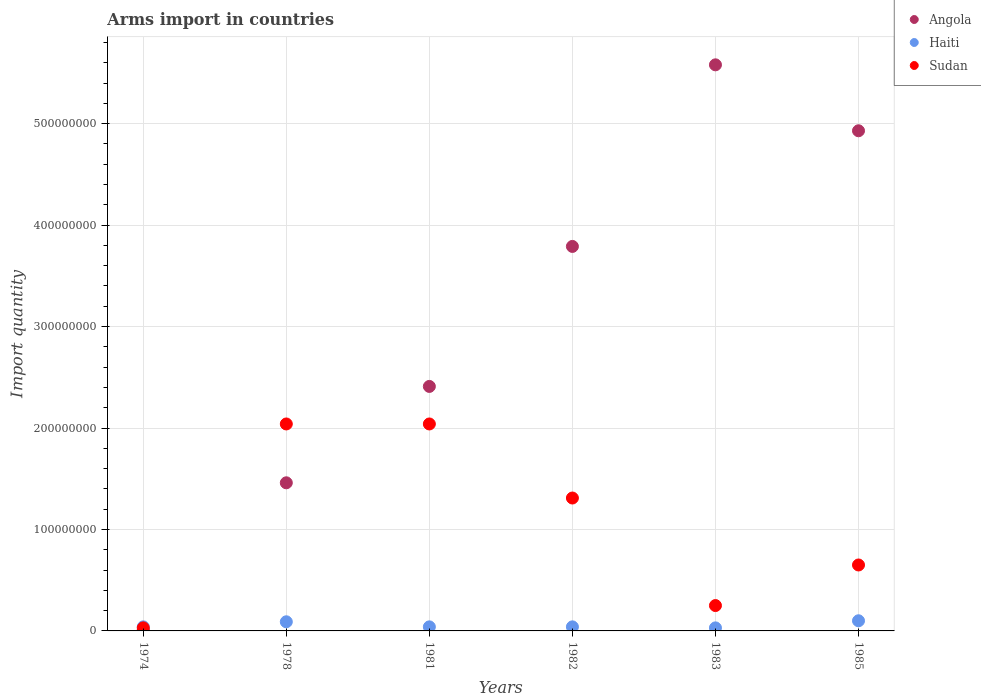What is the total arms import in Angola in 1978?
Offer a very short reply. 1.46e+08. Across all years, what is the maximum total arms import in Haiti?
Ensure brevity in your answer.  1.00e+07. Across all years, what is the minimum total arms import in Haiti?
Provide a short and direct response. 3.00e+06. In which year was the total arms import in Angola minimum?
Give a very brief answer. 1974. What is the total total arms import in Angola in the graph?
Your answer should be very brief. 1.82e+09. What is the difference between the total arms import in Sudan in 1982 and that in 1983?
Your answer should be very brief. 1.06e+08. What is the average total arms import in Angola per year?
Keep it short and to the point. 3.03e+08. In the year 1982, what is the difference between the total arms import in Haiti and total arms import in Angola?
Keep it short and to the point. -3.75e+08. What is the ratio of the total arms import in Haiti in 1974 to that in 1983?
Ensure brevity in your answer.  1.33. Is it the case that in every year, the sum of the total arms import in Sudan and total arms import in Haiti  is greater than the total arms import in Angola?
Offer a very short reply. No. How many dotlines are there?
Your answer should be very brief. 3. How many years are there in the graph?
Give a very brief answer. 6. Are the values on the major ticks of Y-axis written in scientific E-notation?
Offer a terse response. No. Does the graph contain grids?
Ensure brevity in your answer.  Yes. How are the legend labels stacked?
Provide a succinct answer. Vertical. What is the title of the graph?
Offer a terse response. Arms import in countries. Does "Tonga" appear as one of the legend labels in the graph?
Offer a very short reply. No. What is the label or title of the Y-axis?
Offer a terse response. Import quantity. What is the Import quantity of Sudan in 1974?
Make the answer very short. 3.00e+06. What is the Import quantity of Angola in 1978?
Ensure brevity in your answer.  1.46e+08. What is the Import quantity of Haiti in 1978?
Your answer should be very brief. 9.00e+06. What is the Import quantity of Sudan in 1978?
Provide a short and direct response. 2.04e+08. What is the Import quantity in Angola in 1981?
Your response must be concise. 2.41e+08. What is the Import quantity of Sudan in 1981?
Offer a terse response. 2.04e+08. What is the Import quantity of Angola in 1982?
Provide a succinct answer. 3.79e+08. What is the Import quantity in Sudan in 1982?
Offer a very short reply. 1.31e+08. What is the Import quantity of Angola in 1983?
Your answer should be very brief. 5.58e+08. What is the Import quantity of Haiti in 1983?
Offer a terse response. 3.00e+06. What is the Import quantity of Sudan in 1983?
Offer a very short reply. 2.50e+07. What is the Import quantity in Angola in 1985?
Ensure brevity in your answer.  4.93e+08. What is the Import quantity in Sudan in 1985?
Keep it short and to the point. 6.50e+07. Across all years, what is the maximum Import quantity in Angola?
Your answer should be very brief. 5.58e+08. Across all years, what is the maximum Import quantity of Sudan?
Offer a terse response. 2.04e+08. Across all years, what is the minimum Import quantity of Angola?
Ensure brevity in your answer.  1.00e+06. Across all years, what is the minimum Import quantity of Haiti?
Ensure brevity in your answer.  3.00e+06. Across all years, what is the minimum Import quantity in Sudan?
Give a very brief answer. 3.00e+06. What is the total Import quantity in Angola in the graph?
Your response must be concise. 1.82e+09. What is the total Import quantity of Haiti in the graph?
Make the answer very short. 3.40e+07. What is the total Import quantity of Sudan in the graph?
Provide a short and direct response. 6.32e+08. What is the difference between the Import quantity of Angola in 1974 and that in 1978?
Give a very brief answer. -1.45e+08. What is the difference between the Import quantity of Haiti in 1974 and that in 1978?
Provide a short and direct response. -5.00e+06. What is the difference between the Import quantity of Sudan in 1974 and that in 1978?
Ensure brevity in your answer.  -2.01e+08. What is the difference between the Import quantity of Angola in 1974 and that in 1981?
Offer a very short reply. -2.40e+08. What is the difference between the Import quantity of Haiti in 1974 and that in 1981?
Your answer should be very brief. 0. What is the difference between the Import quantity of Sudan in 1974 and that in 1981?
Give a very brief answer. -2.01e+08. What is the difference between the Import quantity of Angola in 1974 and that in 1982?
Your answer should be very brief. -3.78e+08. What is the difference between the Import quantity of Sudan in 1974 and that in 1982?
Give a very brief answer. -1.28e+08. What is the difference between the Import quantity in Angola in 1974 and that in 1983?
Your answer should be compact. -5.57e+08. What is the difference between the Import quantity in Haiti in 1974 and that in 1983?
Provide a succinct answer. 1.00e+06. What is the difference between the Import quantity of Sudan in 1974 and that in 1983?
Your answer should be compact. -2.20e+07. What is the difference between the Import quantity of Angola in 1974 and that in 1985?
Make the answer very short. -4.92e+08. What is the difference between the Import quantity of Haiti in 1974 and that in 1985?
Your answer should be compact. -6.00e+06. What is the difference between the Import quantity in Sudan in 1974 and that in 1985?
Your answer should be very brief. -6.20e+07. What is the difference between the Import quantity of Angola in 1978 and that in 1981?
Your answer should be compact. -9.50e+07. What is the difference between the Import quantity in Haiti in 1978 and that in 1981?
Ensure brevity in your answer.  5.00e+06. What is the difference between the Import quantity in Sudan in 1978 and that in 1981?
Keep it short and to the point. 0. What is the difference between the Import quantity in Angola in 1978 and that in 1982?
Your answer should be compact. -2.33e+08. What is the difference between the Import quantity of Sudan in 1978 and that in 1982?
Provide a succinct answer. 7.30e+07. What is the difference between the Import quantity in Angola in 1978 and that in 1983?
Your answer should be compact. -4.12e+08. What is the difference between the Import quantity of Sudan in 1978 and that in 1983?
Ensure brevity in your answer.  1.79e+08. What is the difference between the Import quantity in Angola in 1978 and that in 1985?
Your response must be concise. -3.47e+08. What is the difference between the Import quantity in Sudan in 1978 and that in 1985?
Your answer should be compact. 1.39e+08. What is the difference between the Import quantity of Angola in 1981 and that in 1982?
Make the answer very short. -1.38e+08. What is the difference between the Import quantity of Sudan in 1981 and that in 1982?
Ensure brevity in your answer.  7.30e+07. What is the difference between the Import quantity of Angola in 1981 and that in 1983?
Your response must be concise. -3.17e+08. What is the difference between the Import quantity in Haiti in 1981 and that in 1983?
Your answer should be very brief. 1.00e+06. What is the difference between the Import quantity in Sudan in 1981 and that in 1983?
Your answer should be compact. 1.79e+08. What is the difference between the Import quantity in Angola in 1981 and that in 1985?
Your answer should be very brief. -2.52e+08. What is the difference between the Import quantity in Haiti in 1981 and that in 1985?
Provide a short and direct response. -6.00e+06. What is the difference between the Import quantity of Sudan in 1981 and that in 1985?
Offer a very short reply. 1.39e+08. What is the difference between the Import quantity of Angola in 1982 and that in 1983?
Offer a terse response. -1.79e+08. What is the difference between the Import quantity in Sudan in 1982 and that in 1983?
Your answer should be compact. 1.06e+08. What is the difference between the Import quantity in Angola in 1982 and that in 1985?
Offer a terse response. -1.14e+08. What is the difference between the Import quantity in Haiti in 1982 and that in 1985?
Offer a terse response. -6.00e+06. What is the difference between the Import quantity of Sudan in 1982 and that in 1985?
Your answer should be compact. 6.60e+07. What is the difference between the Import quantity of Angola in 1983 and that in 1985?
Offer a very short reply. 6.50e+07. What is the difference between the Import quantity of Haiti in 1983 and that in 1985?
Your answer should be very brief. -7.00e+06. What is the difference between the Import quantity in Sudan in 1983 and that in 1985?
Keep it short and to the point. -4.00e+07. What is the difference between the Import quantity in Angola in 1974 and the Import quantity in Haiti in 1978?
Give a very brief answer. -8.00e+06. What is the difference between the Import quantity of Angola in 1974 and the Import quantity of Sudan in 1978?
Your response must be concise. -2.03e+08. What is the difference between the Import quantity of Haiti in 1974 and the Import quantity of Sudan in 1978?
Keep it short and to the point. -2.00e+08. What is the difference between the Import quantity of Angola in 1974 and the Import quantity of Sudan in 1981?
Give a very brief answer. -2.03e+08. What is the difference between the Import quantity in Haiti in 1974 and the Import quantity in Sudan in 1981?
Offer a very short reply. -2.00e+08. What is the difference between the Import quantity in Angola in 1974 and the Import quantity in Haiti in 1982?
Give a very brief answer. -3.00e+06. What is the difference between the Import quantity in Angola in 1974 and the Import quantity in Sudan in 1982?
Provide a succinct answer. -1.30e+08. What is the difference between the Import quantity of Haiti in 1974 and the Import quantity of Sudan in 1982?
Your answer should be compact. -1.27e+08. What is the difference between the Import quantity of Angola in 1974 and the Import quantity of Sudan in 1983?
Provide a short and direct response. -2.40e+07. What is the difference between the Import quantity in Haiti in 1974 and the Import quantity in Sudan in 1983?
Keep it short and to the point. -2.10e+07. What is the difference between the Import quantity in Angola in 1974 and the Import quantity in Haiti in 1985?
Your answer should be compact. -9.00e+06. What is the difference between the Import quantity of Angola in 1974 and the Import quantity of Sudan in 1985?
Provide a short and direct response. -6.40e+07. What is the difference between the Import quantity of Haiti in 1974 and the Import quantity of Sudan in 1985?
Provide a short and direct response. -6.10e+07. What is the difference between the Import quantity of Angola in 1978 and the Import quantity of Haiti in 1981?
Keep it short and to the point. 1.42e+08. What is the difference between the Import quantity of Angola in 1978 and the Import quantity of Sudan in 1981?
Provide a short and direct response. -5.80e+07. What is the difference between the Import quantity in Haiti in 1978 and the Import quantity in Sudan in 1981?
Ensure brevity in your answer.  -1.95e+08. What is the difference between the Import quantity of Angola in 1978 and the Import quantity of Haiti in 1982?
Keep it short and to the point. 1.42e+08. What is the difference between the Import quantity in Angola in 1978 and the Import quantity in Sudan in 1982?
Provide a succinct answer. 1.50e+07. What is the difference between the Import quantity in Haiti in 1978 and the Import quantity in Sudan in 1982?
Provide a succinct answer. -1.22e+08. What is the difference between the Import quantity in Angola in 1978 and the Import quantity in Haiti in 1983?
Your answer should be very brief. 1.43e+08. What is the difference between the Import quantity of Angola in 1978 and the Import quantity of Sudan in 1983?
Keep it short and to the point. 1.21e+08. What is the difference between the Import quantity in Haiti in 1978 and the Import quantity in Sudan in 1983?
Give a very brief answer. -1.60e+07. What is the difference between the Import quantity in Angola in 1978 and the Import quantity in Haiti in 1985?
Give a very brief answer. 1.36e+08. What is the difference between the Import quantity in Angola in 1978 and the Import quantity in Sudan in 1985?
Your response must be concise. 8.10e+07. What is the difference between the Import quantity in Haiti in 1978 and the Import quantity in Sudan in 1985?
Your answer should be compact. -5.60e+07. What is the difference between the Import quantity of Angola in 1981 and the Import quantity of Haiti in 1982?
Your answer should be very brief. 2.37e+08. What is the difference between the Import quantity in Angola in 1981 and the Import quantity in Sudan in 1982?
Keep it short and to the point. 1.10e+08. What is the difference between the Import quantity of Haiti in 1981 and the Import quantity of Sudan in 1982?
Offer a very short reply. -1.27e+08. What is the difference between the Import quantity of Angola in 1981 and the Import quantity of Haiti in 1983?
Ensure brevity in your answer.  2.38e+08. What is the difference between the Import quantity in Angola in 1981 and the Import quantity in Sudan in 1983?
Your response must be concise. 2.16e+08. What is the difference between the Import quantity of Haiti in 1981 and the Import quantity of Sudan in 1983?
Make the answer very short. -2.10e+07. What is the difference between the Import quantity in Angola in 1981 and the Import quantity in Haiti in 1985?
Provide a succinct answer. 2.31e+08. What is the difference between the Import quantity of Angola in 1981 and the Import quantity of Sudan in 1985?
Ensure brevity in your answer.  1.76e+08. What is the difference between the Import quantity of Haiti in 1981 and the Import quantity of Sudan in 1985?
Your response must be concise. -6.10e+07. What is the difference between the Import quantity in Angola in 1982 and the Import quantity in Haiti in 1983?
Make the answer very short. 3.76e+08. What is the difference between the Import quantity of Angola in 1982 and the Import quantity of Sudan in 1983?
Keep it short and to the point. 3.54e+08. What is the difference between the Import quantity of Haiti in 1982 and the Import quantity of Sudan in 1983?
Your answer should be compact. -2.10e+07. What is the difference between the Import quantity of Angola in 1982 and the Import quantity of Haiti in 1985?
Your answer should be compact. 3.69e+08. What is the difference between the Import quantity of Angola in 1982 and the Import quantity of Sudan in 1985?
Give a very brief answer. 3.14e+08. What is the difference between the Import quantity of Haiti in 1982 and the Import quantity of Sudan in 1985?
Ensure brevity in your answer.  -6.10e+07. What is the difference between the Import quantity in Angola in 1983 and the Import quantity in Haiti in 1985?
Make the answer very short. 5.48e+08. What is the difference between the Import quantity of Angola in 1983 and the Import quantity of Sudan in 1985?
Offer a terse response. 4.93e+08. What is the difference between the Import quantity in Haiti in 1983 and the Import quantity in Sudan in 1985?
Make the answer very short. -6.20e+07. What is the average Import quantity of Angola per year?
Give a very brief answer. 3.03e+08. What is the average Import quantity in Haiti per year?
Provide a succinct answer. 5.67e+06. What is the average Import quantity in Sudan per year?
Your answer should be compact. 1.05e+08. In the year 1974, what is the difference between the Import quantity of Angola and Import quantity of Sudan?
Keep it short and to the point. -2.00e+06. In the year 1978, what is the difference between the Import quantity in Angola and Import quantity in Haiti?
Give a very brief answer. 1.37e+08. In the year 1978, what is the difference between the Import quantity of Angola and Import quantity of Sudan?
Give a very brief answer. -5.80e+07. In the year 1978, what is the difference between the Import quantity in Haiti and Import quantity in Sudan?
Your answer should be very brief. -1.95e+08. In the year 1981, what is the difference between the Import quantity in Angola and Import quantity in Haiti?
Provide a succinct answer. 2.37e+08. In the year 1981, what is the difference between the Import quantity of Angola and Import quantity of Sudan?
Offer a very short reply. 3.70e+07. In the year 1981, what is the difference between the Import quantity of Haiti and Import quantity of Sudan?
Provide a succinct answer. -2.00e+08. In the year 1982, what is the difference between the Import quantity in Angola and Import quantity in Haiti?
Provide a succinct answer. 3.75e+08. In the year 1982, what is the difference between the Import quantity of Angola and Import quantity of Sudan?
Ensure brevity in your answer.  2.48e+08. In the year 1982, what is the difference between the Import quantity in Haiti and Import quantity in Sudan?
Your response must be concise. -1.27e+08. In the year 1983, what is the difference between the Import quantity of Angola and Import quantity of Haiti?
Your answer should be very brief. 5.55e+08. In the year 1983, what is the difference between the Import quantity of Angola and Import quantity of Sudan?
Your response must be concise. 5.33e+08. In the year 1983, what is the difference between the Import quantity in Haiti and Import quantity in Sudan?
Give a very brief answer. -2.20e+07. In the year 1985, what is the difference between the Import quantity in Angola and Import quantity in Haiti?
Provide a succinct answer. 4.83e+08. In the year 1985, what is the difference between the Import quantity in Angola and Import quantity in Sudan?
Offer a terse response. 4.28e+08. In the year 1985, what is the difference between the Import quantity of Haiti and Import quantity of Sudan?
Keep it short and to the point. -5.50e+07. What is the ratio of the Import quantity in Angola in 1974 to that in 1978?
Provide a succinct answer. 0.01. What is the ratio of the Import quantity of Haiti in 1974 to that in 1978?
Provide a short and direct response. 0.44. What is the ratio of the Import quantity in Sudan in 1974 to that in 1978?
Offer a very short reply. 0.01. What is the ratio of the Import quantity in Angola in 1974 to that in 1981?
Give a very brief answer. 0. What is the ratio of the Import quantity of Sudan in 1974 to that in 1981?
Provide a succinct answer. 0.01. What is the ratio of the Import quantity of Angola in 1974 to that in 1982?
Provide a short and direct response. 0. What is the ratio of the Import quantity in Haiti in 1974 to that in 1982?
Offer a terse response. 1. What is the ratio of the Import quantity in Sudan in 1974 to that in 1982?
Make the answer very short. 0.02. What is the ratio of the Import quantity of Angola in 1974 to that in 1983?
Provide a short and direct response. 0. What is the ratio of the Import quantity in Sudan in 1974 to that in 1983?
Offer a terse response. 0.12. What is the ratio of the Import quantity of Angola in 1974 to that in 1985?
Offer a terse response. 0. What is the ratio of the Import quantity in Sudan in 1974 to that in 1985?
Provide a short and direct response. 0.05. What is the ratio of the Import quantity of Angola in 1978 to that in 1981?
Give a very brief answer. 0.61. What is the ratio of the Import quantity in Haiti in 1978 to that in 1981?
Your answer should be compact. 2.25. What is the ratio of the Import quantity of Angola in 1978 to that in 1982?
Keep it short and to the point. 0.39. What is the ratio of the Import quantity in Haiti in 1978 to that in 1982?
Make the answer very short. 2.25. What is the ratio of the Import quantity in Sudan in 1978 to that in 1982?
Give a very brief answer. 1.56. What is the ratio of the Import quantity of Angola in 1978 to that in 1983?
Provide a succinct answer. 0.26. What is the ratio of the Import quantity of Haiti in 1978 to that in 1983?
Your answer should be compact. 3. What is the ratio of the Import quantity of Sudan in 1978 to that in 1983?
Offer a very short reply. 8.16. What is the ratio of the Import quantity of Angola in 1978 to that in 1985?
Your answer should be very brief. 0.3. What is the ratio of the Import quantity in Haiti in 1978 to that in 1985?
Provide a short and direct response. 0.9. What is the ratio of the Import quantity in Sudan in 1978 to that in 1985?
Your response must be concise. 3.14. What is the ratio of the Import quantity of Angola in 1981 to that in 1982?
Your answer should be compact. 0.64. What is the ratio of the Import quantity in Haiti in 1981 to that in 1982?
Provide a short and direct response. 1. What is the ratio of the Import quantity in Sudan in 1981 to that in 1982?
Your response must be concise. 1.56. What is the ratio of the Import quantity of Angola in 1981 to that in 1983?
Your answer should be compact. 0.43. What is the ratio of the Import quantity of Sudan in 1981 to that in 1983?
Provide a short and direct response. 8.16. What is the ratio of the Import quantity of Angola in 1981 to that in 1985?
Ensure brevity in your answer.  0.49. What is the ratio of the Import quantity in Haiti in 1981 to that in 1985?
Your answer should be compact. 0.4. What is the ratio of the Import quantity of Sudan in 1981 to that in 1985?
Ensure brevity in your answer.  3.14. What is the ratio of the Import quantity of Angola in 1982 to that in 1983?
Your answer should be compact. 0.68. What is the ratio of the Import quantity of Haiti in 1982 to that in 1983?
Provide a short and direct response. 1.33. What is the ratio of the Import quantity of Sudan in 1982 to that in 1983?
Offer a terse response. 5.24. What is the ratio of the Import quantity of Angola in 1982 to that in 1985?
Your answer should be very brief. 0.77. What is the ratio of the Import quantity in Haiti in 1982 to that in 1985?
Offer a terse response. 0.4. What is the ratio of the Import quantity of Sudan in 1982 to that in 1985?
Offer a very short reply. 2.02. What is the ratio of the Import quantity in Angola in 1983 to that in 1985?
Make the answer very short. 1.13. What is the ratio of the Import quantity in Sudan in 1983 to that in 1985?
Provide a short and direct response. 0.38. What is the difference between the highest and the second highest Import quantity in Angola?
Provide a succinct answer. 6.50e+07. What is the difference between the highest and the second highest Import quantity in Haiti?
Keep it short and to the point. 1.00e+06. What is the difference between the highest and the lowest Import quantity of Angola?
Your answer should be very brief. 5.57e+08. What is the difference between the highest and the lowest Import quantity in Sudan?
Keep it short and to the point. 2.01e+08. 